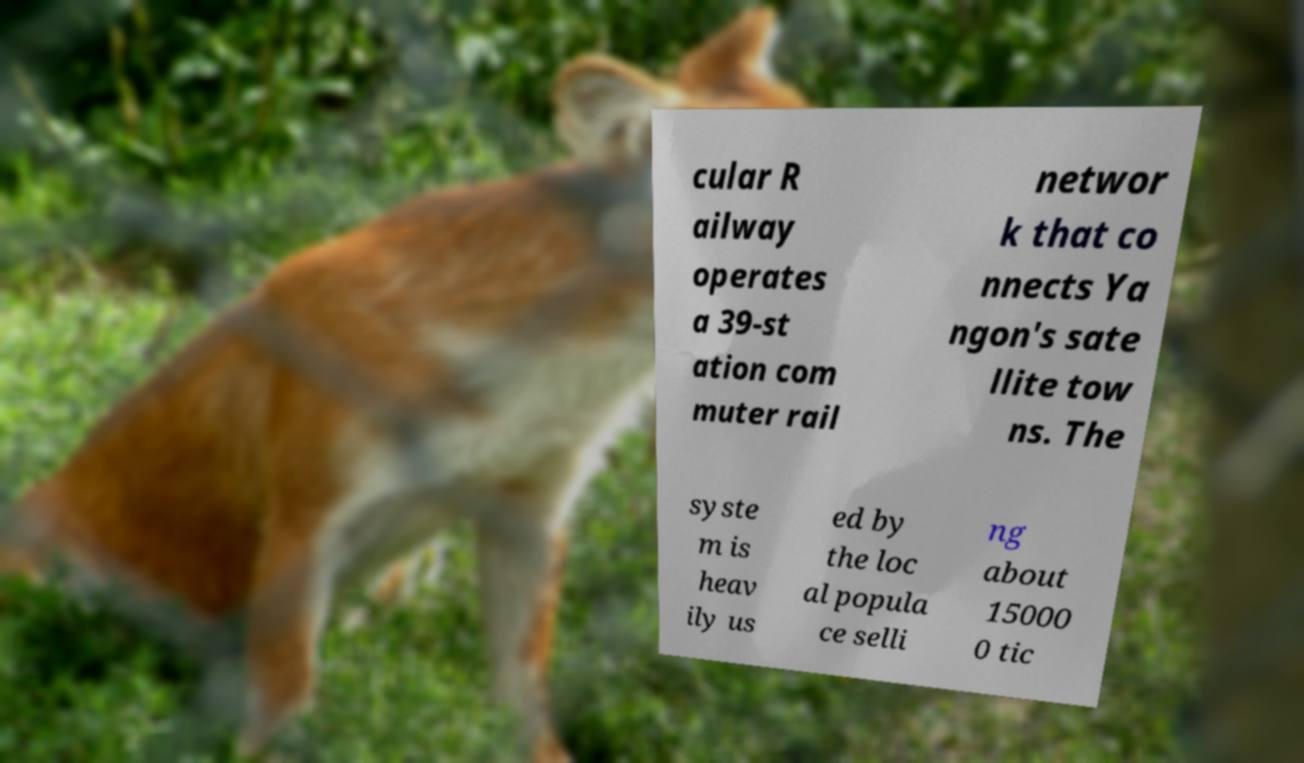Can you accurately transcribe the text from the provided image for me? cular R ailway operates a 39-st ation com muter rail networ k that co nnects Ya ngon's sate llite tow ns. The syste m is heav ily us ed by the loc al popula ce selli ng about 15000 0 tic 